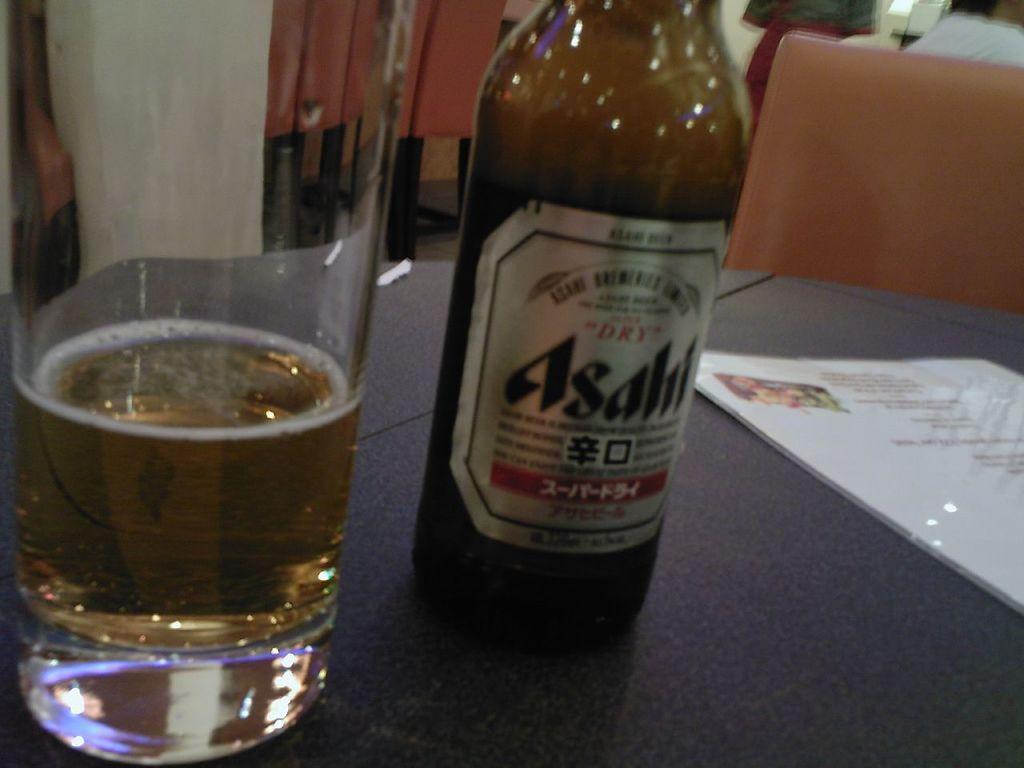Describe this image in one or two sentences. This image is taken in indoors. In this image there is a table and on top of that there is a wine bottle, a glass with wine and a menu card on it. At the background there are few empty chairs and a wall. 